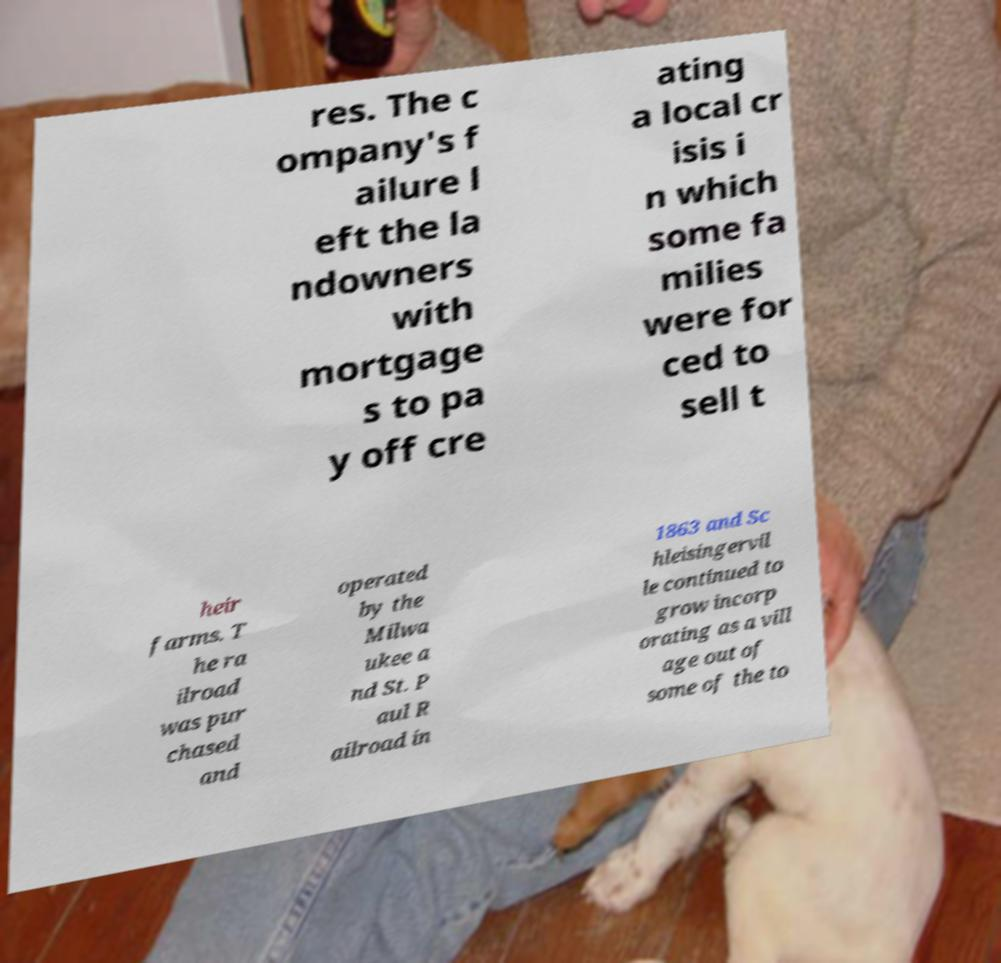Could you extract and type out the text from this image? res. The c ompany's f ailure l eft the la ndowners with mortgage s to pa y off cre ating a local cr isis i n which some fa milies were for ced to sell t heir farms. T he ra ilroad was pur chased and operated by the Milwa ukee a nd St. P aul R ailroad in 1863 and Sc hleisingervil le continued to grow incorp orating as a vill age out of some of the to 